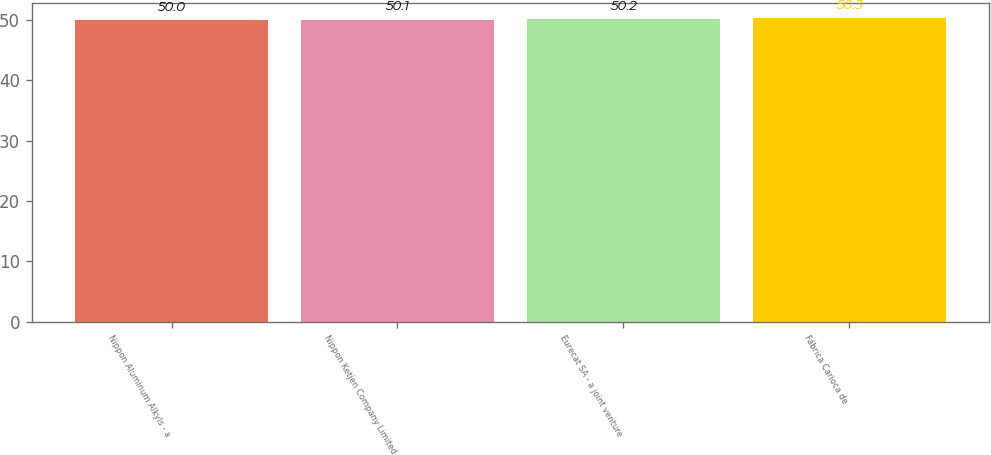Convert chart. <chart><loc_0><loc_0><loc_500><loc_500><bar_chart><fcel>Nippon Aluminum Alkyls - a<fcel>Nippon Ketjen Company Limited<fcel>Eurecat SA - a joint venture<fcel>Fábrica Carioca de<nl><fcel>50<fcel>50.1<fcel>50.2<fcel>50.3<nl></chart> 